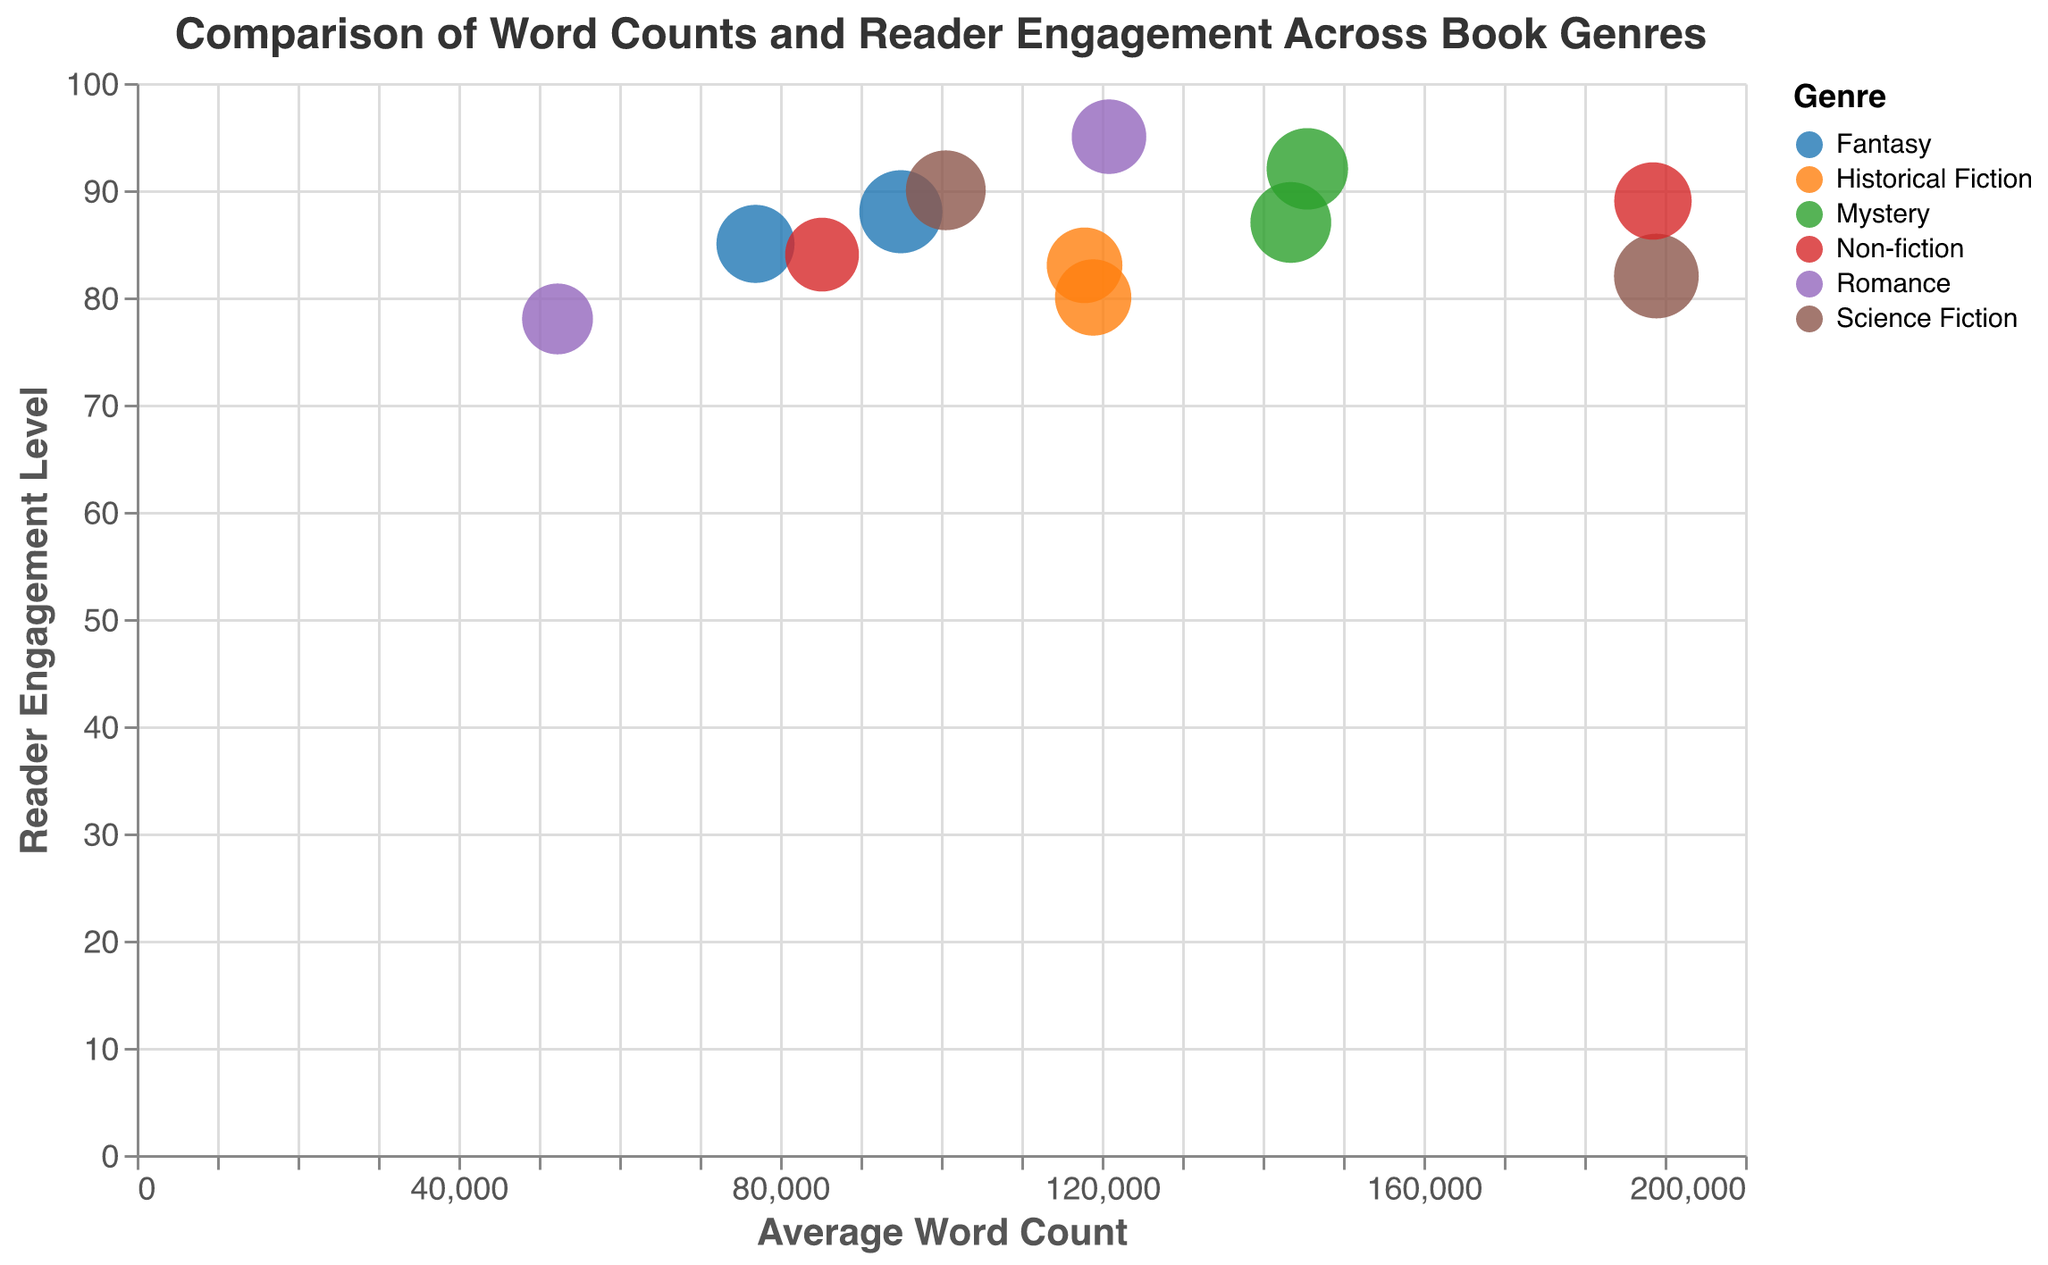How many genres are compared in the plot? The plot legend shows the colors representing different genres. By counting them, we find there are six distinct genres.
Answer: Six Which book has the highest reader engagement level? By examining the y-axis values, "Pride and Prejudice" (in Romance) has the highest engagement level at 95.
Answer: "Pride and Prejudice" Which book has the largest bubble size and what does it represent? The book "Dune" (in Science Fiction) has the largest bubble size, which indicates its bubble size to be 120.
Answer: "Dune" Compare the reader engagement levels of "Dune" and "Ender's Game". "Dune" has a reader engagement level of 82, while "Ender’s Game" has a level of 90, thus "Ender’s Game" has a higher engagement level.
Answer: "Ender's Game" Which genre has the book with the lowest average word count and what is the title of that book? By looking at the x-axis values, "The Notebook" in the Romance genre has the lowest average word count at 52,328.
Answer: "The Notebook" What is the average reader engagement level for the Mystery genre books in the plot? Mystery has two books: "Gone Girl" (92) and "The Girl with the Dragon Tattoo" (87). The average is calculated as (92 + 87) / 2 = 89.5.
Answer: 89.5 Which genre's books generally have higher reader engagement levels, Romance or Non-fiction? Romance ("Pride and Prejudice" 95 and "The Notebook" 78) averages to (95+78) / 2 = 86.5. Non-fiction ("Sapiens" 89 and "Educated" 84) averages to (89+84) / 2 = 86.5. They have the same average engagement level.
Answer: Equal Identify the book with the highest average word count and its reader engagement level. "Dune" (in Science Fiction) has the highest average word count of 188970, with a reader engagement level of 82.
Answer: "Dune" with 82 What is the difference in reader engagement levels between the books "Harry Potter and the Philosopher's Stone" and "The Notebook"? "Harry Potter and the Philosopher's Stone" has an engagement level of 85, whereas "The Notebook" has 78. Their difference is 85 - 78 = 7.
Answer: 7 